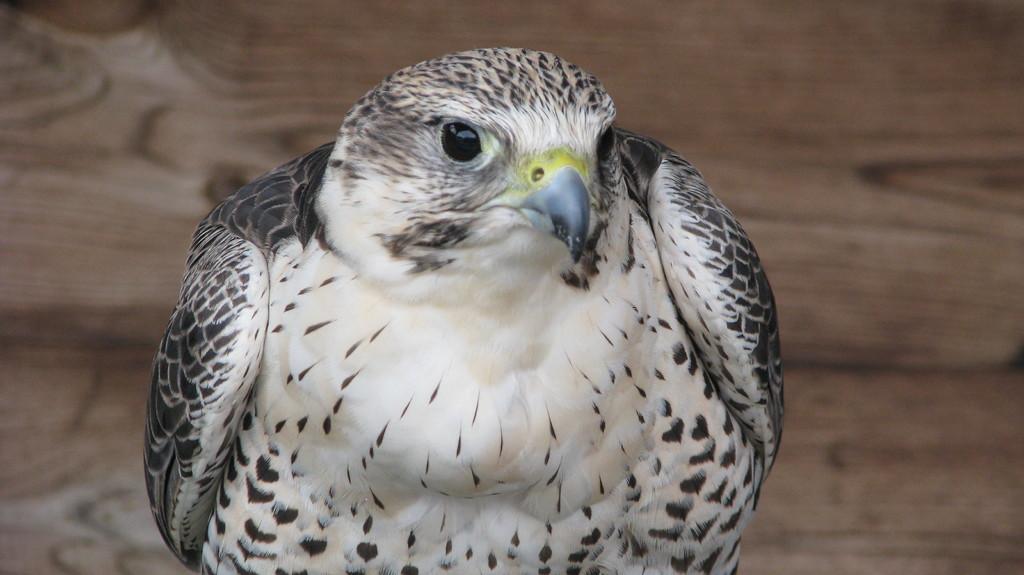Please provide a concise description of this image. In the image we can see a bird, white, black, gray and yellow in color and there is a wooden surface. 